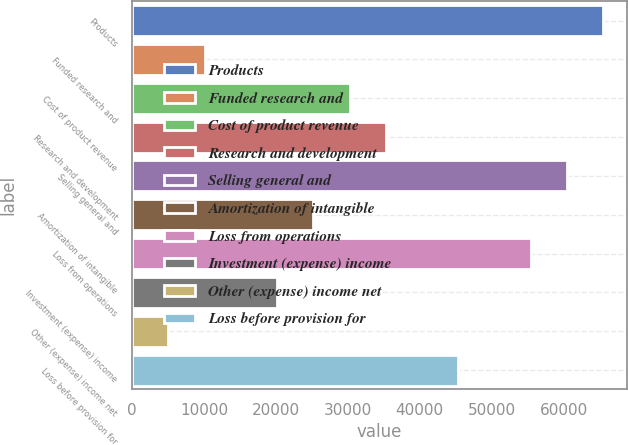<chart> <loc_0><loc_0><loc_500><loc_500><bar_chart><fcel>Products<fcel>Funded research and<fcel>Cost of product revenue<fcel>Research and development<fcel>Selling general and<fcel>Amortization of intangible<fcel>Loss from operations<fcel>Investment (expense) income<fcel>Other (expense) income net<fcel>Loss before provision for<nl><fcel>65530.1<fcel>10082.4<fcel>30245.2<fcel>35285.9<fcel>60489.4<fcel>25204.5<fcel>55448.7<fcel>20163.8<fcel>5041.73<fcel>45367.3<nl></chart> 